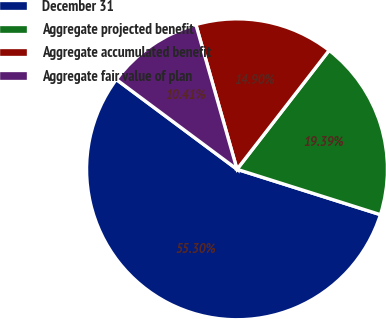Convert chart. <chart><loc_0><loc_0><loc_500><loc_500><pie_chart><fcel>December 31<fcel>Aggregate projected benefit<fcel>Aggregate accumulated benefit<fcel>Aggregate fair value of plan<nl><fcel>55.31%<fcel>19.39%<fcel>14.9%<fcel>10.41%<nl></chart> 